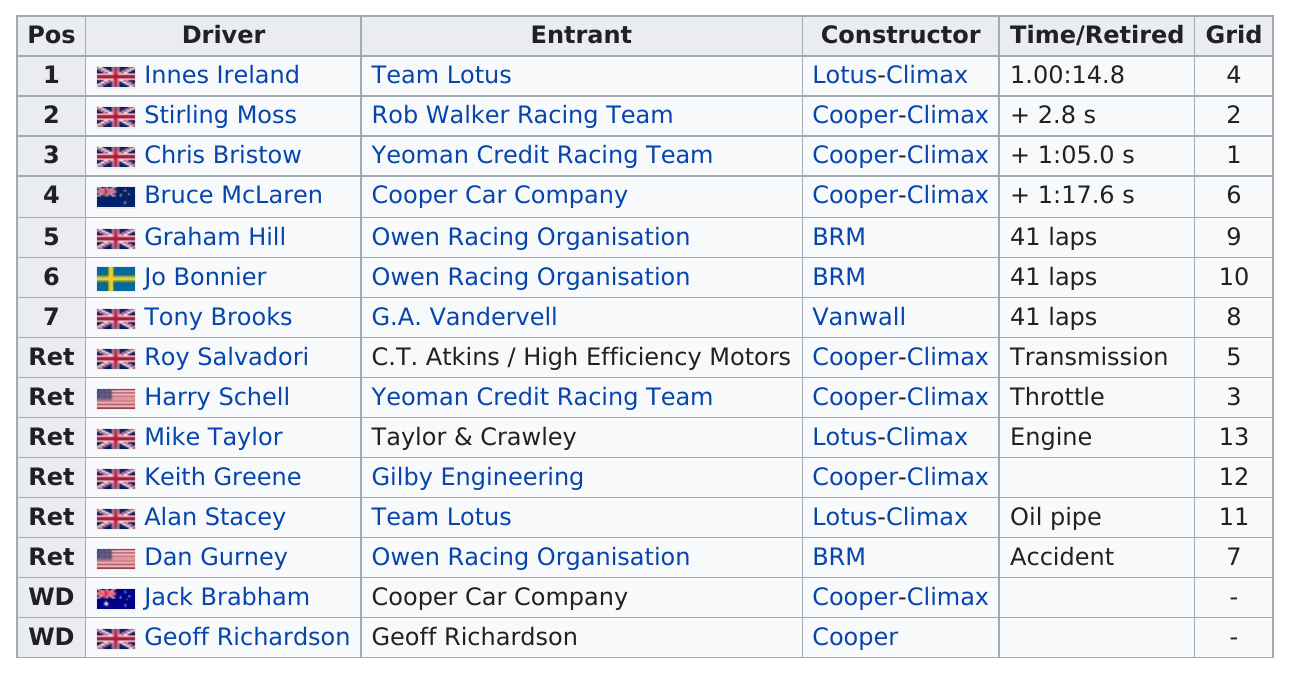List a handful of essential elements in this visual. There are approximately 10 million UK drivers. The 8th Glover Trophy race involved 15 drivers participating. The total number of American drivers is 2. Innes Ireland is in the first position. The first place was won by the drive, with Innes Ireland as the winner. 